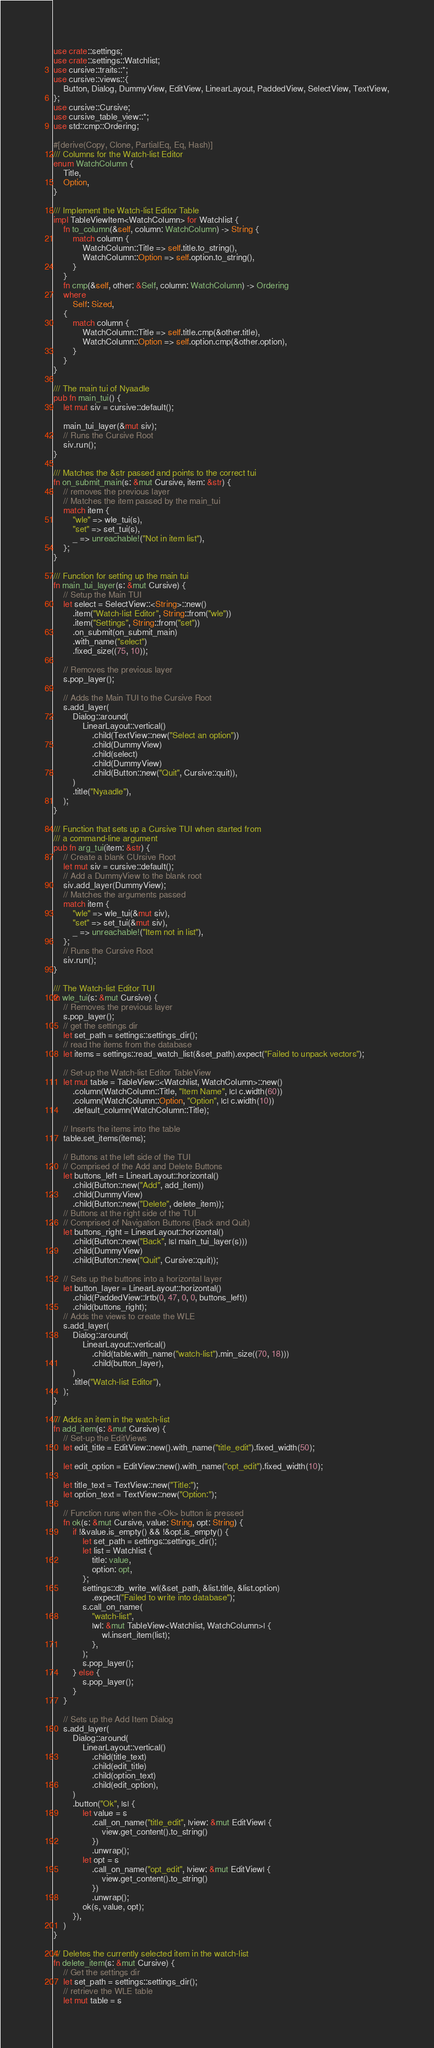<code> <loc_0><loc_0><loc_500><loc_500><_Rust_>use crate::settings;
use crate::settings::Watchlist;
use cursive::traits::*;
use cursive::views::{
    Button, Dialog, DummyView, EditView, LinearLayout, PaddedView, SelectView, TextView,
};
use cursive::Cursive;
use cursive_table_view::*;
use std::cmp::Ordering;

#[derive(Copy, Clone, PartialEq, Eq, Hash)]
/// Columns for the Watch-list Editor
enum WatchColumn {
    Title,
    Option,
}

/// Implement the Watch-list Editor Table
impl TableViewItem<WatchColumn> for Watchlist {
    fn to_column(&self, column: WatchColumn) -> String {
        match column {
            WatchColumn::Title => self.title.to_string(),
            WatchColumn::Option => self.option.to_string(),
        }
    }
    fn cmp(&self, other: &Self, column: WatchColumn) -> Ordering
    where
        Self: Sized,
    {
        match column {
            WatchColumn::Title => self.title.cmp(&other.title),
            WatchColumn::Option => self.option.cmp(&other.option),
        }
    }
}

/// The main tui of Nyaadle
pub fn main_tui() {
    let mut siv = cursive::default();

    main_tui_layer(&mut siv);
    // Runs the Cursive Root
    siv.run();
}

/// Matches the &str passed and points to the correct tui
fn on_submit_main(s: &mut Cursive, item: &str) {
    // removes the previous layer
    // Matches the item passed by the main_tui
    match item {
        "wle" => wle_tui(s),
        "set" => set_tui(s),
        _ => unreachable!("Not in item list"),
    };
}

/// Function for setting up the main tui
fn main_tui_layer(s: &mut Cursive) {
    // Setup the Main TUI
    let select = SelectView::<String>::new()
        .item("Watch-list Editor", String::from("wle"))
        .item("Settings", String::from("set"))
        .on_submit(on_submit_main)
        .with_name("select")
        .fixed_size((75, 10));

    // Removes the previous layer
    s.pop_layer();

    // Adds the Main TUI to the Cursive Root
    s.add_layer(
        Dialog::around(
            LinearLayout::vertical()
                .child(TextView::new("Select an option"))
                .child(DummyView)
                .child(select)
                .child(DummyView)
                .child(Button::new("Quit", Cursive::quit)),
        )
        .title("Nyaadle"),
    );
}

/// Function that sets up a Cursive TUI when started from
/// a command-line argument
pub fn arg_tui(item: &str) {
    // Create a blank CUrsive Root
    let mut siv = cursive::default();
    // Add a DummyView to the blank root
    siv.add_layer(DummyView);
    // Matches the arguments passed
    match item {
        "wle" => wle_tui(&mut siv),
        "set" => set_tui(&mut siv),
        _ => unreachable!("Item not in list"),
    };
    // Runs the Cursive Root
    siv.run();
}

/// The Watch-list Editor TUI
fn wle_tui(s: &mut Cursive) {
    // Removes the previous layer
    s.pop_layer();
    // get the settings dir
    let set_path = settings::settings_dir();
    // read the items from the database
    let items = settings::read_watch_list(&set_path).expect("Failed to unpack vectors");

    // Set-up the Watch-list Editor TableView
    let mut table = TableView::<Watchlist, WatchColumn>::new()
        .column(WatchColumn::Title, "Item Name", |c| c.width(60))
        .column(WatchColumn::Option, "Option", |c| c.width(10))
        .default_column(WatchColumn::Title);

    // Inserts the items into the table
    table.set_items(items);

    // Buttons at the left side of the TUI
    // Comprised of the Add and Delete Buttons
    let buttons_left = LinearLayout::horizontal()
        .child(Button::new("Add", add_item))
        .child(DummyView)
        .child(Button::new("Delete", delete_item));
    // Buttons at the right side of the TUI
    // Comprised of Navigation Buttons (Back and Quit)
    let buttons_right = LinearLayout::horizontal()
        .child(Button::new("Back", |s| main_tui_layer(s)))
        .child(DummyView)
        .child(Button::new("Quit", Cursive::quit));

    // Sets up the buttons into a horizontal layer
    let button_layer = LinearLayout::horizontal()
        .child(PaddedView::lrtb(0, 47, 0, 0, buttons_left))
        .child(buttons_right);
    // Adds the views to create the WLE
    s.add_layer(
        Dialog::around(
            LinearLayout::vertical()
                .child(table.with_name("watch-list").min_size((70, 18)))
                .child(button_layer),
        )
        .title("Watch-list Editor"),
    );
}

/// Adds an item in the watch-list
fn add_item(s: &mut Cursive) {
    // Set-up the EditViews
    let edit_title = EditView::new().with_name("title_edit").fixed_width(50);

    let edit_option = EditView::new().with_name("opt_edit").fixed_width(10);

    let title_text = TextView::new("Title:");
    let option_text = TextView::new("Option:");

    // Function runs when the <Ok> button is pressed
    fn ok(s: &mut Cursive, value: String, opt: String) {
        if !&value.is_empty() && !&opt.is_empty() {
            let set_path = settings::settings_dir();
            let list = Watchlist {
                title: value,
                option: opt,
            };
            settings::db_write_wl(&set_path, &list.title, &list.option)
                .expect("Failed to write into database");
            s.call_on_name(
                "watch-list",
                |wl: &mut TableView<Watchlist, WatchColumn>| {
                    wl.insert_item(list);
                },
            );
            s.pop_layer();
        } else {
            s.pop_layer();
        }
    }

    // Sets up the Add Item Dialog
    s.add_layer(
        Dialog::around(
            LinearLayout::vertical()
                .child(title_text)
                .child(edit_title)
                .child(option_text)
                .child(edit_option),
        )
        .button("Ok", |s| {
            let value = s
                .call_on_name("title_edit", |view: &mut EditView| {
                    view.get_content().to_string()
                })
                .unwrap();
            let opt = s
                .call_on_name("opt_edit", |view: &mut EditView| {
                    view.get_content().to_string()
                })
                .unwrap();
            ok(s, value, opt);
        }),
    )
}

/// Deletes the currently selected item in the watch-list
fn delete_item(s: &mut Cursive) {
    // Get the settings dir
    let set_path = settings::settings_dir();
    // retrieve the WLE table
    let mut table = s</code> 